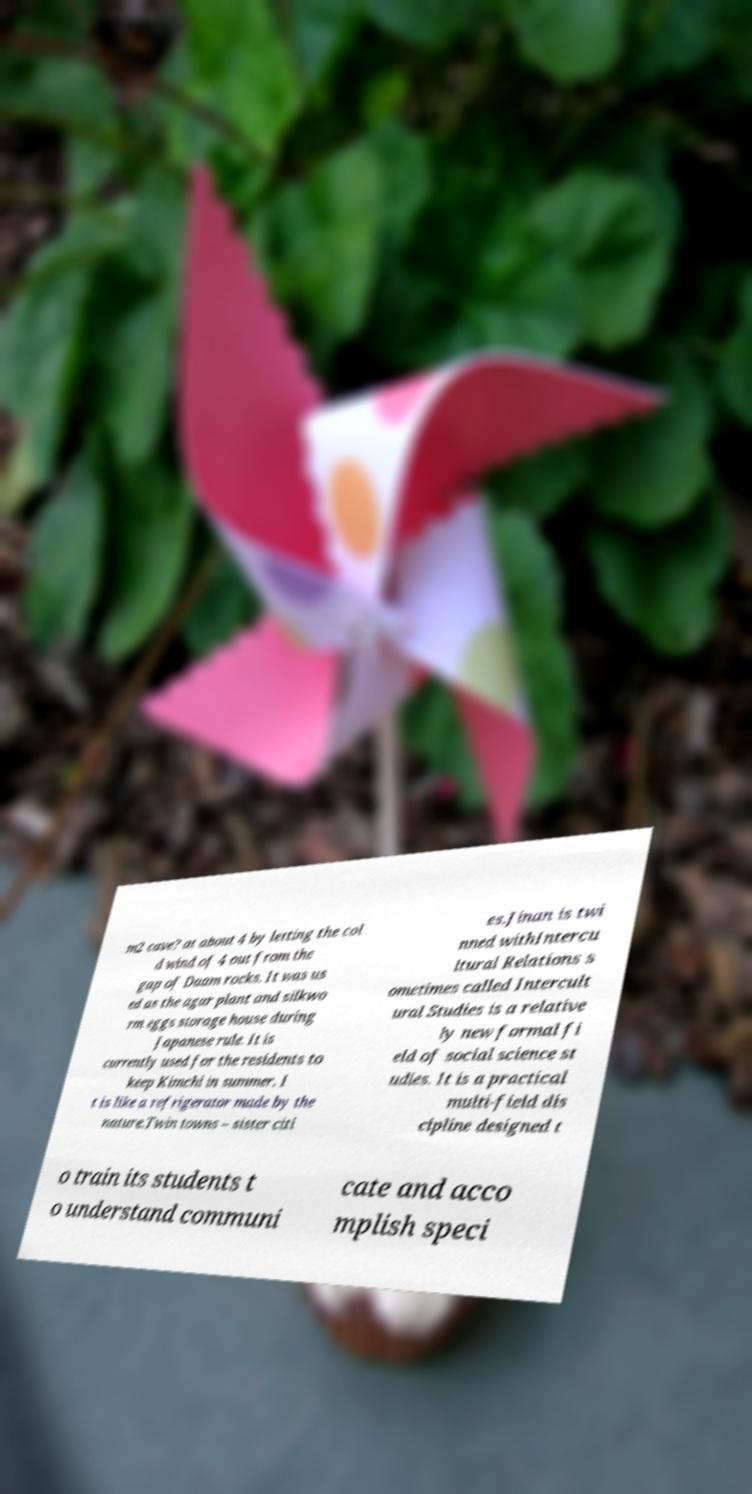For documentation purposes, I need the text within this image transcribed. Could you provide that? m2 cave? at about 4 by letting the col d wind of 4 out from the gap of Daam rocks. It was us ed as the agar plant and silkwo rm eggs storage house during Japanese rule. It is currently used for the residents to keep Kimchi in summer. I t is like a refrigerator made by the nature.Twin towns – sister citi es.Jinan is twi nned withIntercu ltural Relations s ometimes called Intercult ural Studies is a relative ly new formal fi eld of social science st udies. It is a practical multi-field dis cipline designed t o train its students t o understand communi cate and acco mplish speci 